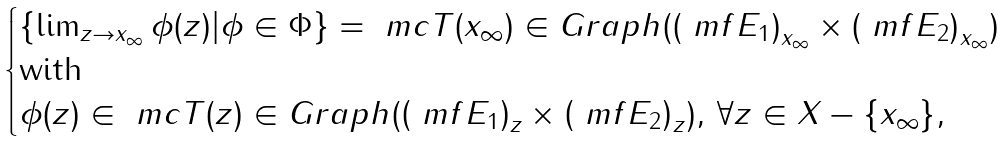Convert formula to latex. <formula><loc_0><loc_0><loc_500><loc_500>\begin{cases} \left \{ \lim _ { z \to x _ { \infty } } \phi ( z ) | \phi \in \Phi \right \} = \ m c { T } ( x _ { \infty } ) \in G r a p h ( \left ( \ m f { E } _ { 1 } \right ) _ { x _ { \infty } } \times \left ( \ m f { E } _ { 2 } \right ) _ { x _ { \infty } } ) \\ \text {with} \\ \phi ( z ) \in \ m c { T } ( z ) \in G r a p h ( \left ( \ m f { E } _ { 1 } \right ) _ { z } \times \left ( \ m f { E } _ { 2 } \right ) _ { z } ) , \, \forall z \in X - \{ x _ { \infty } \} , \end{cases}</formula> 